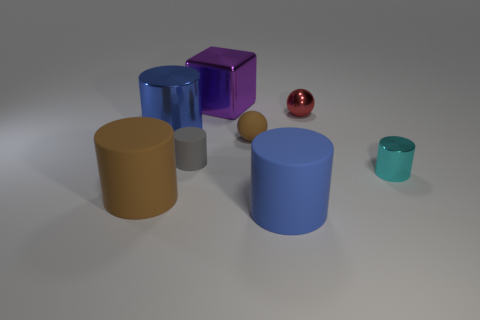There is a rubber thing that is both behind the small cyan metallic object and to the right of the small rubber cylinder; what size is it?
Offer a very short reply. Small. Is the number of purple metallic things greater than the number of blue objects?
Provide a succinct answer. No. Are there any big matte cylinders that have the same color as the big shiny cylinder?
Ensure brevity in your answer.  Yes. There is a blue cylinder that is in front of the blue shiny object; does it have the same size as the tiny cyan thing?
Your answer should be compact. No. Are there fewer big brown objects than large red metallic cubes?
Offer a terse response. No. Is there a purple sphere made of the same material as the big brown cylinder?
Your response must be concise. No. There is a brown object that is left of the gray matte thing; what shape is it?
Provide a short and direct response. Cylinder. Do the small ball that is left of the big blue rubber cylinder and the small rubber cylinder have the same color?
Offer a very short reply. No. Are there fewer metallic things in front of the cyan shiny thing than brown shiny blocks?
Keep it short and to the point. No. What color is the other tiny cylinder that is made of the same material as the brown cylinder?
Keep it short and to the point. Gray. 